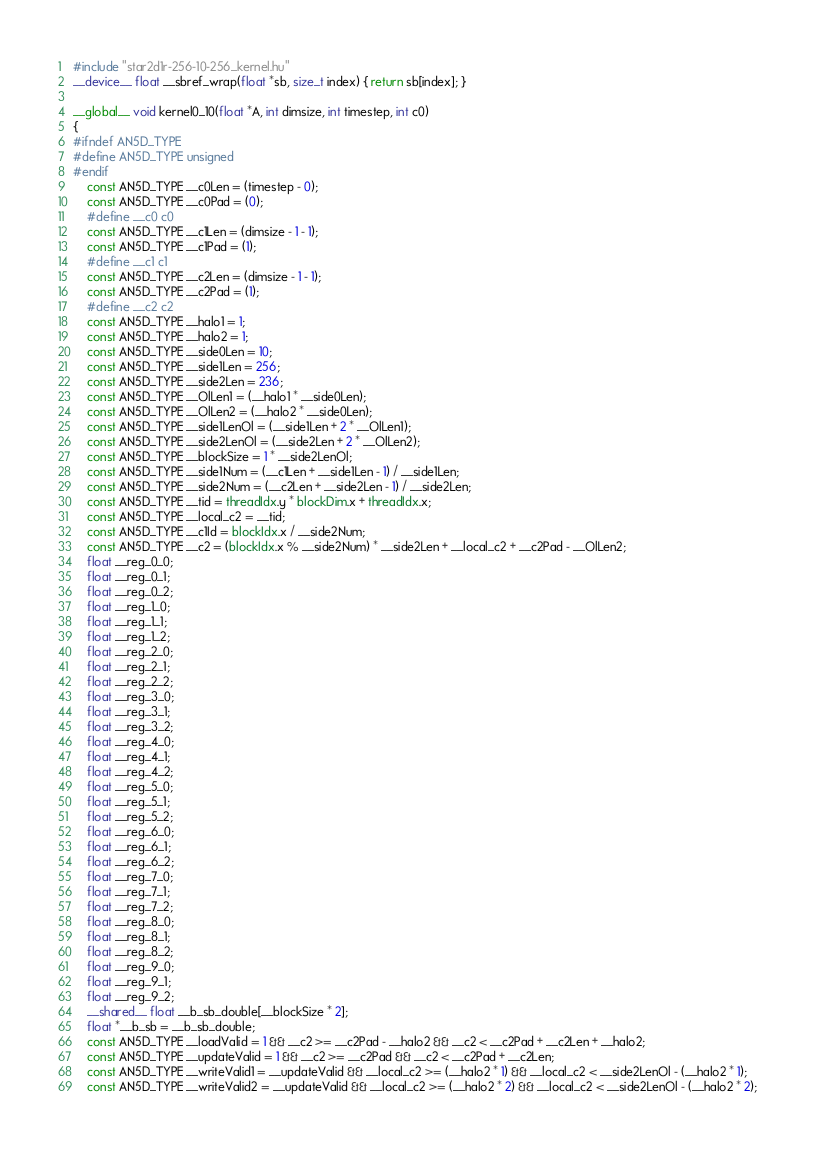<code> <loc_0><loc_0><loc_500><loc_500><_Cuda_>#include "star2d1r-256-10-256_kernel.hu"
__device__ float __sbref_wrap(float *sb, size_t index) { return sb[index]; }

__global__ void kernel0_10(float *A, int dimsize, int timestep, int c0)
{
#ifndef AN5D_TYPE
#define AN5D_TYPE unsigned
#endif
    const AN5D_TYPE __c0Len = (timestep - 0);
    const AN5D_TYPE __c0Pad = (0);
    #define __c0 c0
    const AN5D_TYPE __c1Len = (dimsize - 1 - 1);
    const AN5D_TYPE __c1Pad = (1);
    #define __c1 c1
    const AN5D_TYPE __c2Len = (dimsize - 1 - 1);
    const AN5D_TYPE __c2Pad = (1);
    #define __c2 c2
    const AN5D_TYPE __halo1 = 1;
    const AN5D_TYPE __halo2 = 1;
    const AN5D_TYPE __side0Len = 10;
    const AN5D_TYPE __side1Len = 256;
    const AN5D_TYPE __side2Len = 236;
    const AN5D_TYPE __OlLen1 = (__halo1 * __side0Len);
    const AN5D_TYPE __OlLen2 = (__halo2 * __side0Len);
    const AN5D_TYPE __side1LenOl = (__side1Len + 2 * __OlLen1);
    const AN5D_TYPE __side2LenOl = (__side2Len + 2 * __OlLen2);
    const AN5D_TYPE __blockSize = 1 * __side2LenOl;
    const AN5D_TYPE __side1Num = (__c1Len + __side1Len - 1) / __side1Len;
    const AN5D_TYPE __side2Num = (__c2Len + __side2Len - 1) / __side2Len;
    const AN5D_TYPE __tid = threadIdx.y * blockDim.x + threadIdx.x;
    const AN5D_TYPE __local_c2 = __tid;
    const AN5D_TYPE __c1Id = blockIdx.x / __side2Num;
    const AN5D_TYPE __c2 = (blockIdx.x % __side2Num) * __side2Len + __local_c2 + __c2Pad - __OlLen2;
    float __reg_0_0;
    float __reg_0_1;
    float __reg_0_2;
    float __reg_1_0;
    float __reg_1_1;
    float __reg_1_2;
    float __reg_2_0;
    float __reg_2_1;
    float __reg_2_2;
    float __reg_3_0;
    float __reg_3_1;
    float __reg_3_2;
    float __reg_4_0;
    float __reg_4_1;
    float __reg_4_2;
    float __reg_5_0;
    float __reg_5_1;
    float __reg_5_2;
    float __reg_6_0;
    float __reg_6_1;
    float __reg_6_2;
    float __reg_7_0;
    float __reg_7_1;
    float __reg_7_2;
    float __reg_8_0;
    float __reg_8_1;
    float __reg_8_2;
    float __reg_9_0;
    float __reg_9_1;
    float __reg_9_2;
    __shared__ float __b_sb_double[__blockSize * 2];
    float *__b_sb = __b_sb_double;
    const AN5D_TYPE __loadValid = 1 && __c2 >= __c2Pad - __halo2 && __c2 < __c2Pad + __c2Len + __halo2;
    const AN5D_TYPE __updateValid = 1 && __c2 >= __c2Pad && __c2 < __c2Pad + __c2Len;
    const AN5D_TYPE __writeValid1 = __updateValid && __local_c2 >= (__halo2 * 1) && __local_c2 < __side2LenOl - (__halo2 * 1);
    const AN5D_TYPE __writeValid2 = __updateValid && __local_c2 >= (__halo2 * 2) && __local_c2 < __side2LenOl - (__halo2 * 2);</code> 